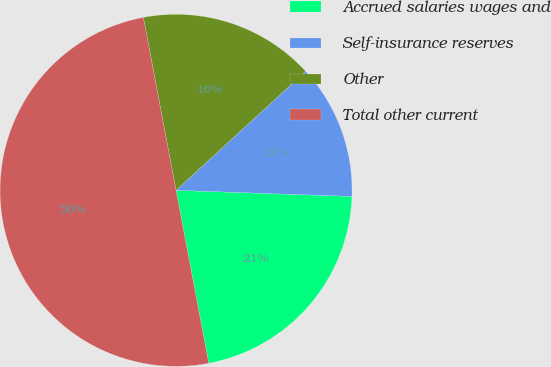Convert chart. <chart><loc_0><loc_0><loc_500><loc_500><pie_chart><fcel>Accrued salaries wages and<fcel>Self-insurance reserves<fcel>Other<fcel>Total other current<nl><fcel>21.47%<fcel>12.38%<fcel>16.15%<fcel>50.0%<nl></chart> 